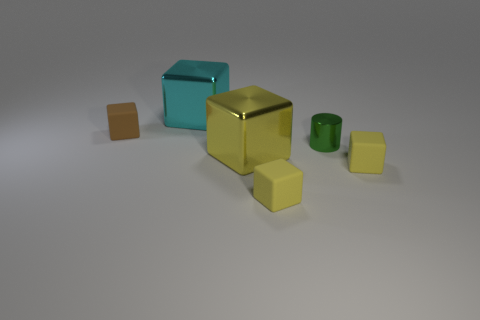Is the small green object made of the same material as the thing to the right of the tiny green thing?
Your answer should be compact. No. What number of blocks are on the right side of the brown thing and on the left side of the yellow metal object?
Ensure brevity in your answer.  1. There is another thing that is the same size as the yellow metallic thing; what shape is it?
Offer a terse response. Cube. Is there a matte thing that is behind the tiny rubber thing that is behind the small yellow rubber block that is to the right of the green object?
Give a very brief answer. No. There is a tiny shiny cylinder; is it the same color as the big object that is to the left of the large yellow metal thing?
Your response must be concise. No. How many other cylinders are the same color as the tiny cylinder?
Your response must be concise. 0. What is the size of the cylinder in front of the tiny rubber block that is behind the yellow shiny thing?
Provide a short and direct response. Small. How many things are either small rubber objects right of the small brown rubber object or big yellow blocks?
Your answer should be compact. 3. Is there a green metallic object that has the same size as the green shiny cylinder?
Make the answer very short. No. Is there a shiny block on the right side of the large metallic thing behind the small brown cube?
Provide a short and direct response. Yes. 